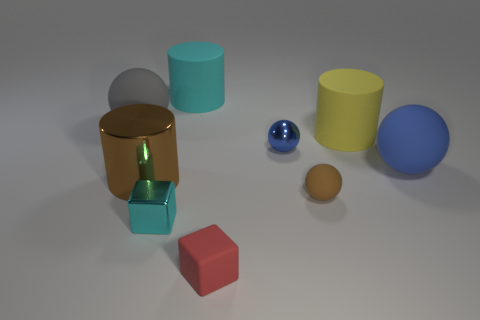Is the tiny brown object made of the same material as the small cube in front of the small cyan metallic object?
Keep it short and to the point. Yes. There is a rubber sphere that is the same size as the red rubber object; what color is it?
Offer a very short reply. Brown. What size is the cylinder that is on the right side of the blue ball behind the blue matte thing?
Offer a terse response. Large. There is a rubber cube; is it the same color as the rubber ball in front of the brown metallic cylinder?
Give a very brief answer. No. Is the number of large gray balls in front of the brown metallic cylinder less than the number of big matte spheres?
Your response must be concise. Yes. What number of other objects are there of the same size as the blue metallic ball?
Provide a succinct answer. 3. Does the object that is behind the gray rubber object have the same shape as the blue metal thing?
Provide a short and direct response. No. Is the number of big blue things that are in front of the large shiny cylinder greater than the number of large yellow matte cylinders?
Provide a succinct answer. No. What is the thing that is both on the left side of the cyan metallic thing and on the right side of the big gray rubber sphere made of?
Make the answer very short. Metal. Is there any other thing that is the same shape as the large yellow object?
Ensure brevity in your answer.  Yes. 